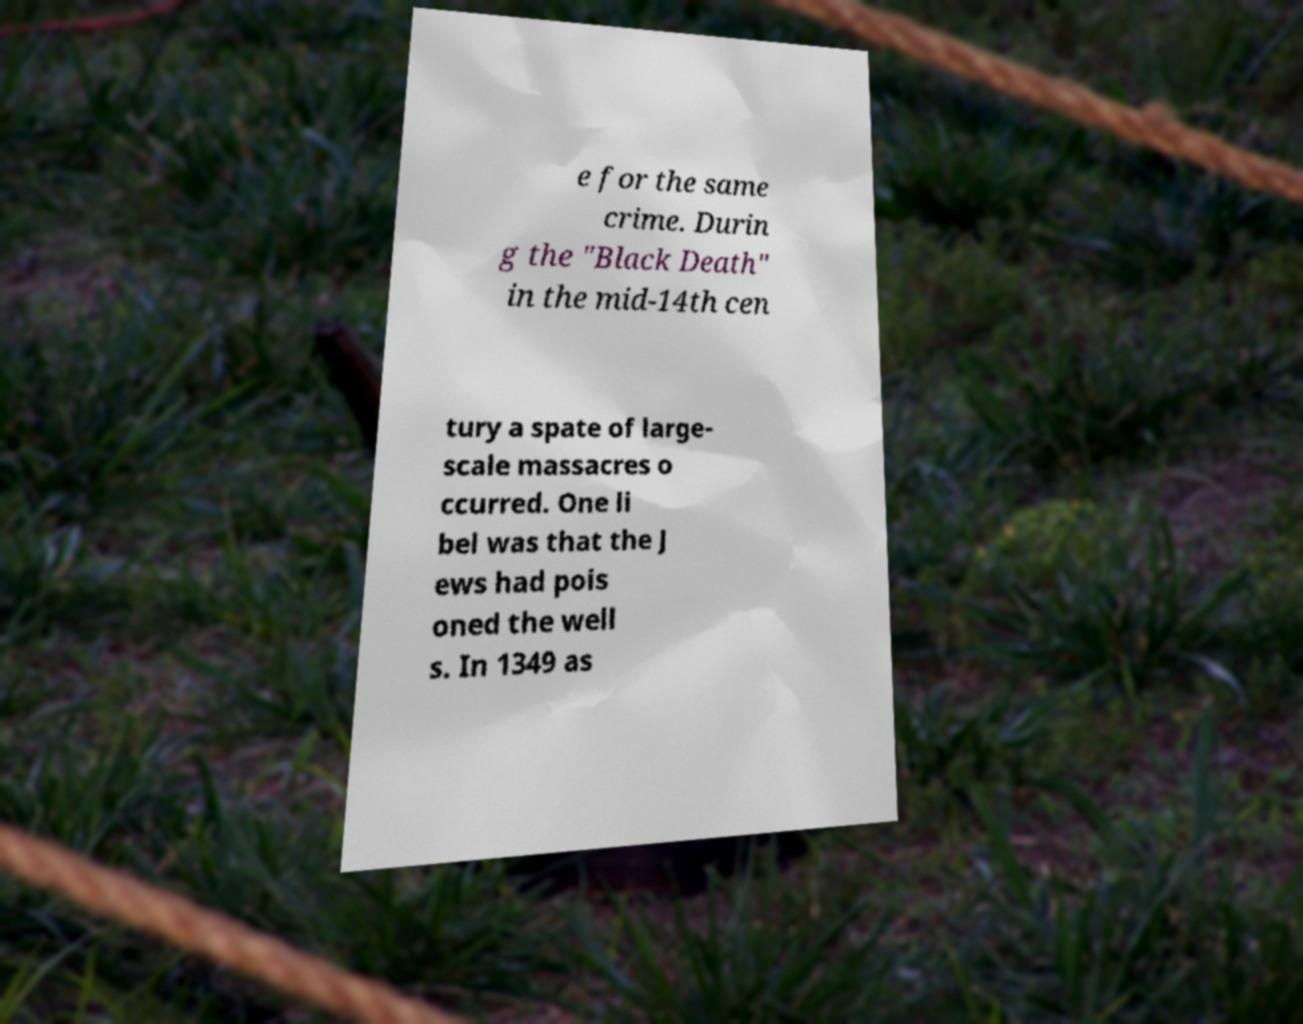Can you accurately transcribe the text from the provided image for me? e for the same crime. Durin g the "Black Death" in the mid-14th cen tury a spate of large- scale massacres o ccurred. One li bel was that the J ews had pois oned the well s. In 1349 as 